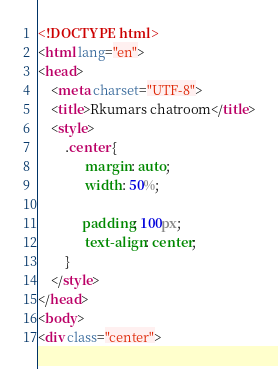Convert code to text. <code><loc_0><loc_0><loc_500><loc_500><_HTML_><!DOCTYPE html>
<html lang="en">
<head>
    <meta charset="UTF-8">
    <title>Rkumars chatroom</title>
    <style>
        .center {
              margin: auto;
              width: 50%;

             padding: 100px;
              text-align: center;
        }
    </style>
</head>
<body>
<div class="center"></code> 